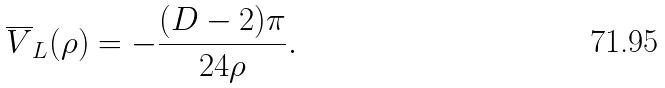Convert formula to latex. <formula><loc_0><loc_0><loc_500><loc_500>\overline { V } _ { L } ( \rho ) = - \frac { ( D - 2 ) \pi } { 2 4 \rho } .</formula> 